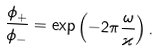<formula> <loc_0><loc_0><loc_500><loc_500>\frac { \phi _ { + } } { \phi _ { - } } = \exp \left ( - 2 \pi \frac { \omega } { \varkappa } \right ) .</formula> 